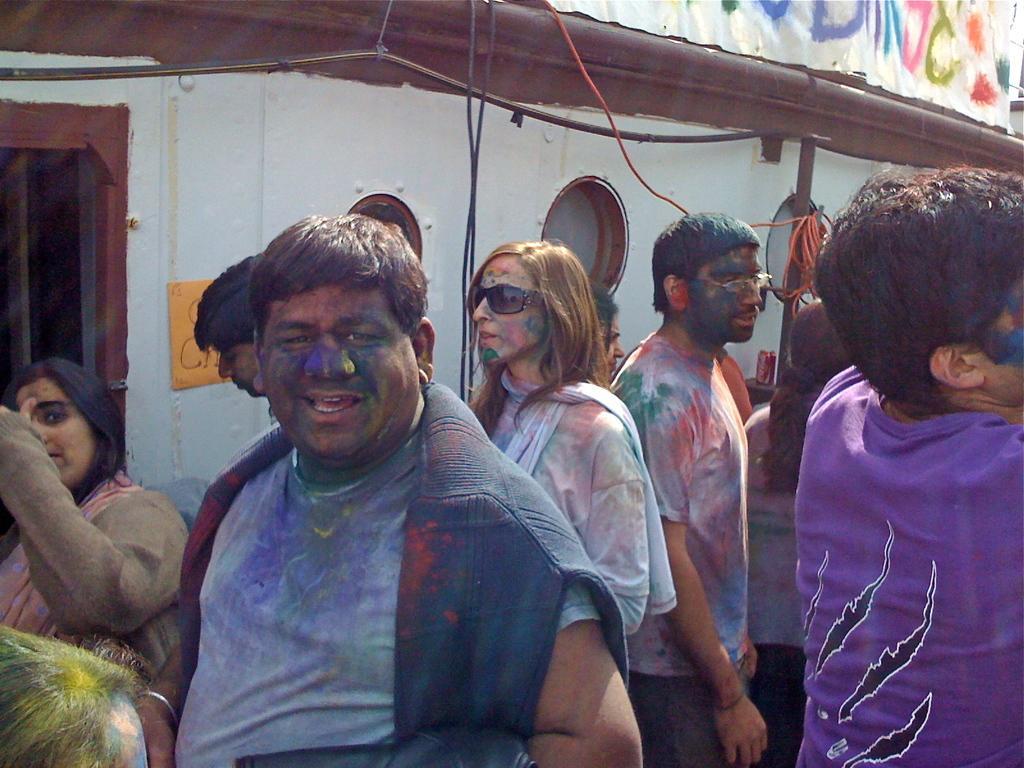Can you describe this image briefly? There are few people here and their faces and clothes are rubbed with different types of colors. In the background there is a wall,cables and a text written on an object. 